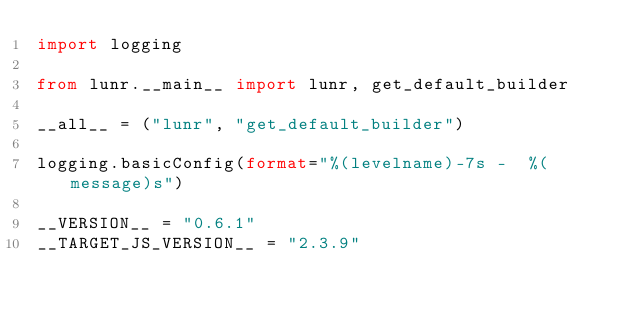Convert code to text. <code><loc_0><loc_0><loc_500><loc_500><_Python_>import logging

from lunr.__main__ import lunr, get_default_builder

__all__ = ("lunr", "get_default_builder")

logging.basicConfig(format="%(levelname)-7s -  %(message)s")

__VERSION__ = "0.6.1"
__TARGET_JS_VERSION__ = "2.3.9"
</code> 